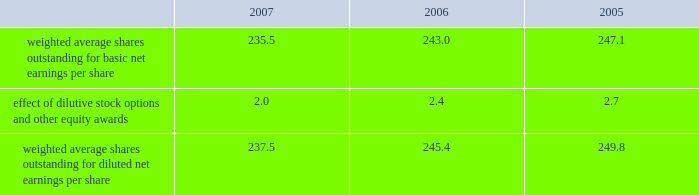Our tax returns are currently under examination in various foreign jurisdictions .
The major foreign tax jurisdictions under examination include germany , italy and switzerland .
It is reasonably possible that such audits will be resolved in the next twelve months , but we do not anticipate that the resolution of these audits would result in any material impact on our results of operations or financial position .
12 .
Capital stock and earnings per share we have 2 million shares of series a participating cumulative preferred stock authorized for issuance , none of which were outstanding as of december 31 , 2007 .
The numerator for both basic and diluted earnings per share is net earnings available to common stockholders .
The denominator for basic earnings per share is the weighted average number of common shares outstanding during the period .
The denominator for diluted earnings per share is weighted average shares outstanding adjusted for the effect of dilutive stock options and other equity awards .
The following is a reconciliation of weighted average shares for the basic and diluted share computations for the years ending december 31 ( in millions ) : .
Weighted average shares outstanding for basic net earnings per share 235.5 243.0 247.1 effect of dilutive stock options and other equity awards 2.0 2.4 2.7 weighted average shares outstanding for diluted net earnings per share 237.5 245.4 249.8 for the year ended december 31 , 2007 , an average of 3.1 million options to purchase shares of common stock were not included in the computation of diluted earnings per share as the exercise prices of these options were greater than the average market price of the common stock .
For the years ended december 31 , 2006 and 2005 , an average of 7.6 million and 2.9 million options , respectively , were not included .
In december 2005 , our board of directors authorized a stock repurchase program of up to $ 1 billion through december 31 , 2007 .
In december 2006 , our board of directors authorized an additional stock repurchase program of up to $ 1 billion through december 31 , 2008 .
As of december 31 , 2007 we had acquired approximately 19345200 shares at a cost of $ 1378.9 million , before commissions .
13 .
Segment data we design , develop , manufacture and market reconstructive orthopaedic implants , including joint and dental , spinal implants , trauma products and related orthopaedic surgical products which include surgical supplies and instruments designed to aid in orthopaedic surgical procedures and post-operation rehabilitation .
We also provide other healthcare related services .
Revenue related to these services currently represents less than 1 percent of our total net sales .
We manage operations through three major geographic segments 2013 the americas , which is comprised principally of the united states and includes other north , central and south american markets ; europe , which is comprised principally of europe and includes the middle east and africa ; and asia pacific , which is comprised primarily of japan and includes other asian and pacific markets .
This structure is the basis for our reportable segment information discussed below .
Management evaluates operating segment performance based upon segment operating profit exclusive of operating expenses pertaining to global operations and corporate expenses , share-based compensation expense , settlement , acquisition , integration and other expenses , inventory step-up , in-process research and development write- offs and intangible asset amortization expense .
Global operations include research , development engineering , medical education , brand management , corporate legal , finance , and human resource functions , and u.s .
And puerto rico based manufacturing operations and logistics .
Intercompany transactions have been eliminated from segment operating profit .
Management reviews accounts receivable , inventory , property , plant and equipment , goodwill and intangible assets by reportable segment exclusive of u.s and puerto rico based manufacturing operations and logistics and corporate assets .
Z i m m e r h o l d i n g s , i n c .
2 0 0 7 f o r m 1 0 - k a n n u a l r e p o r t notes to consolidated financial statements ( continued ) .
What is the change in weighted average shares outstanding for diluted net earnings per share between 2005 and 2006 , in millions? 
Computations: (245.4 - 249.8)
Answer: -4.4. Our tax returns are currently under examination in various foreign jurisdictions .
The major foreign tax jurisdictions under examination include germany , italy and switzerland .
It is reasonably possible that such audits will be resolved in the next twelve months , but we do not anticipate that the resolution of these audits would result in any material impact on our results of operations or financial position .
12 .
Capital stock and earnings per share we have 2 million shares of series a participating cumulative preferred stock authorized for issuance , none of which were outstanding as of december 31 , 2007 .
The numerator for both basic and diluted earnings per share is net earnings available to common stockholders .
The denominator for basic earnings per share is the weighted average number of common shares outstanding during the period .
The denominator for diluted earnings per share is weighted average shares outstanding adjusted for the effect of dilutive stock options and other equity awards .
The following is a reconciliation of weighted average shares for the basic and diluted share computations for the years ending december 31 ( in millions ) : .
Weighted average shares outstanding for basic net earnings per share 235.5 243.0 247.1 effect of dilutive stock options and other equity awards 2.0 2.4 2.7 weighted average shares outstanding for diluted net earnings per share 237.5 245.4 249.8 for the year ended december 31 , 2007 , an average of 3.1 million options to purchase shares of common stock were not included in the computation of diluted earnings per share as the exercise prices of these options were greater than the average market price of the common stock .
For the years ended december 31 , 2006 and 2005 , an average of 7.6 million and 2.9 million options , respectively , were not included .
In december 2005 , our board of directors authorized a stock repurchase program of up to $ 1 billion through december 31 , 2007 .
In december 2006 , our board of directors authorized an additional stock repurchase program of up to $ 1 billion through december 31 , 2008 .
As of december 31 , 2007 we had acquired approximately 19345200 shares at a cost of $ 1378.9 million , before commissions .
13 .
Segment data we design , develop , manufacture and market reconstructive orthopaedic implants , including joint and dental , spinal implants , trauma products and related orthopaedic surgical products which include surgical supplies and instruments designed to aid in orthopaedic surgical procedures and post-operation rehabilitation .
We also provide other healthcare related services .
Revenue related to these services currently represents less than 1 percent of our total net sales .
We manage operations through three major geographic segments 2013 the americas , which is comprised principally of the united states and includes other north , central and south american markets ; europe , which is comprised principally of europe and includes the middle east and africa ; and asia pacific , which is comprised primarily of japan and includes other asian and pacific markets .
This structure is the basis for our reportable segment information discussed below .
Management evaluates operating segment performance based upon segment operating profit exclusive of operating expenses pertaining to global operations and corporate expenses , share-based compensation expense , settlement , acquisition , integration and other expenses , inventory step-up , in-process research and development write- offs and intangible asset amortization expense .
Global operations include research , development engineering , medical education , brand management , corporate legal , finance , and human resource functions , and u.s .
And puerto rico based manufacturing operations and logistics .
Intercompany transactions have been eliminated from segment operating profit .
Management reviews accounts receivable , inventory , property , plant and equipment , goodwill and intangible assets by reportable segment exclusive of u.s and puerto rico based manufacturing operations and logistics and corporate assets .
Z i m m e r h o l d i n g s , i n c .
2 0 0 7 f o r m 1 0 - k a n n u a l r e p o r t notes to consolidated financial statements ( continued ) .
What percent did the value of basic weight shares outstanding change from 2005 to 2007? 
Computations: ((235.5 / 247.1) - 1)
Answer: -0.04694. 